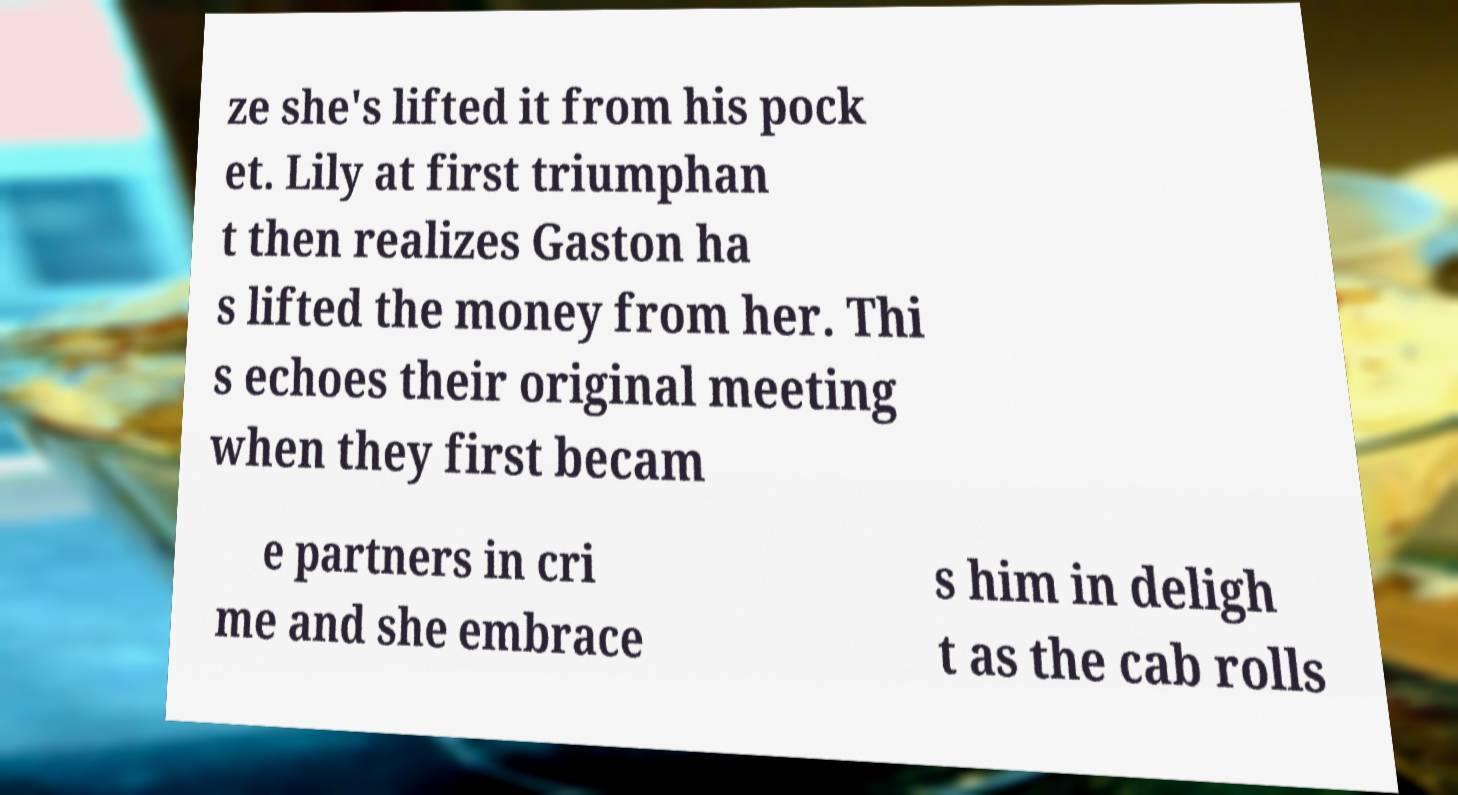Could you extract and type out the text from this image? ze she's lifted it from his pock et. Lily at first triumphan t then realizes Gaston ha s lifted the money from her. Thi s echoes their original meeting when they first becam e partners in cri me and she embrace s him in deligh t as the cab rolls 